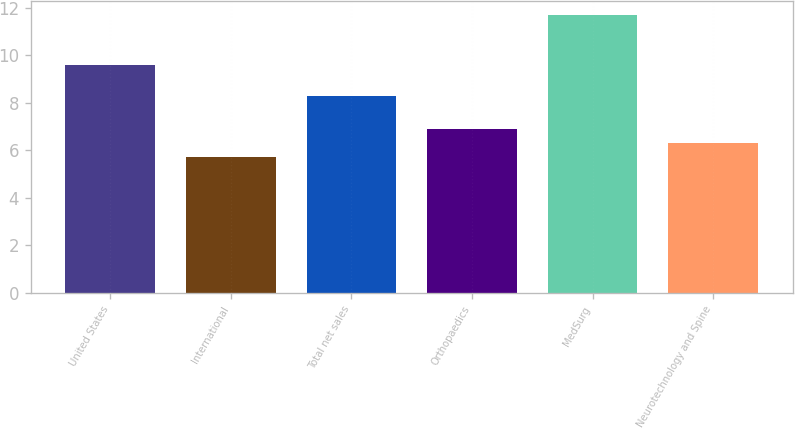Convert chart. <chart><loc_0><loc_0><loc_500><loc_500><bar_chart><fcel>United States<fcel>International<fcel>Total net sales<fcel>Orthopaedics<fcel>MedSurg<fcel>Neurotechnology and Spine<nl><fcel>9.6<fcel>5.7<fcel>8.3<fcel>6.9<fcel>11.7<fcel>6.3<nl></chart> 